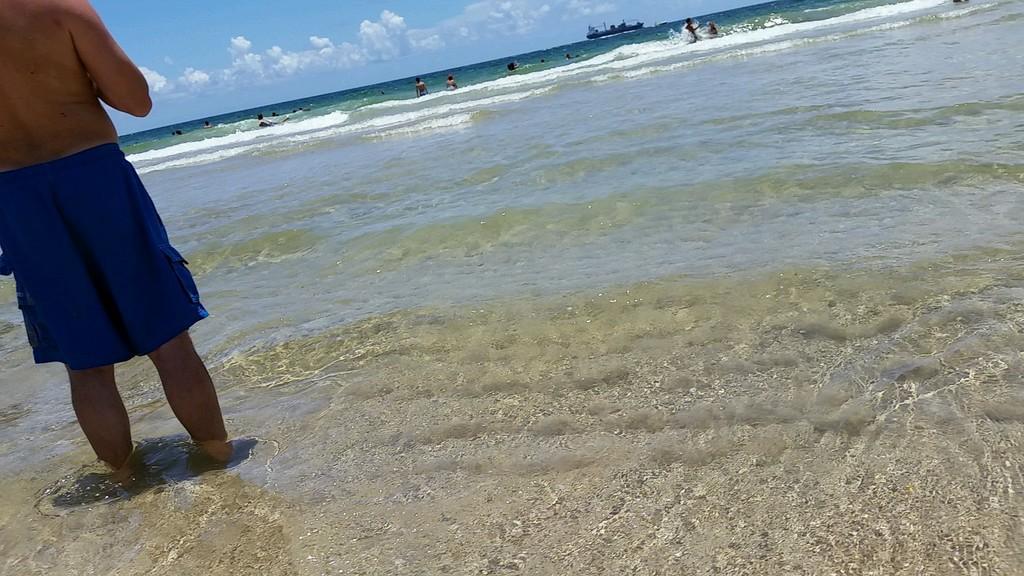Please provide a concise description of this image. In this image there is a person standing in the water, and there are group of people in the water, a boat on the water, and in the background there is sky. 